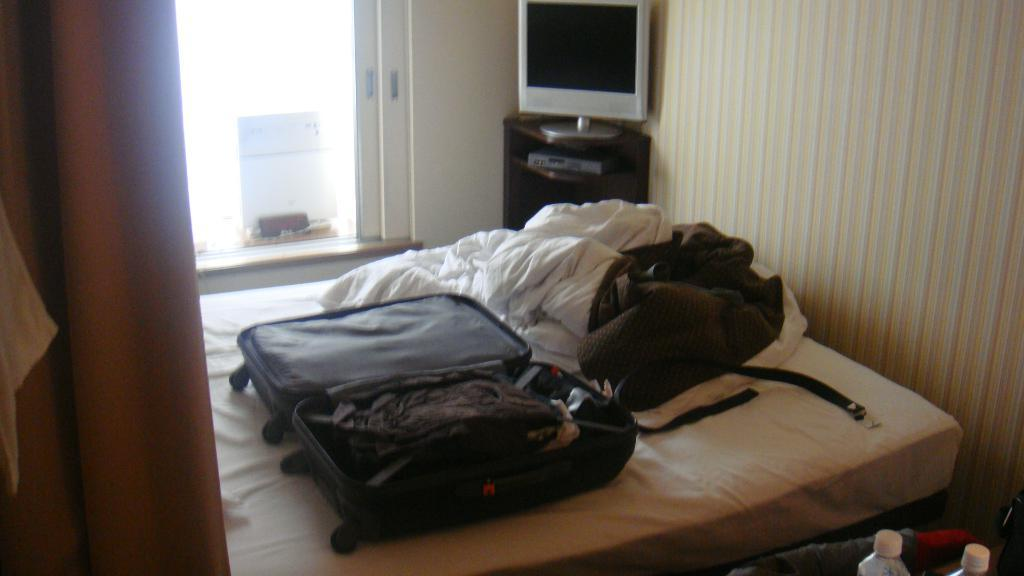What piece of furniture is present in the image? There is a bed in the image. What is placed on the bed? Luggage bags and clothes are placed on the bed. What can be seen in the background of the image? There is a television on a table and a wall in the background. What type of reaction can be seen from the foot in the image? There is no foot present in the image, so it is not possible to determine any reaction. 